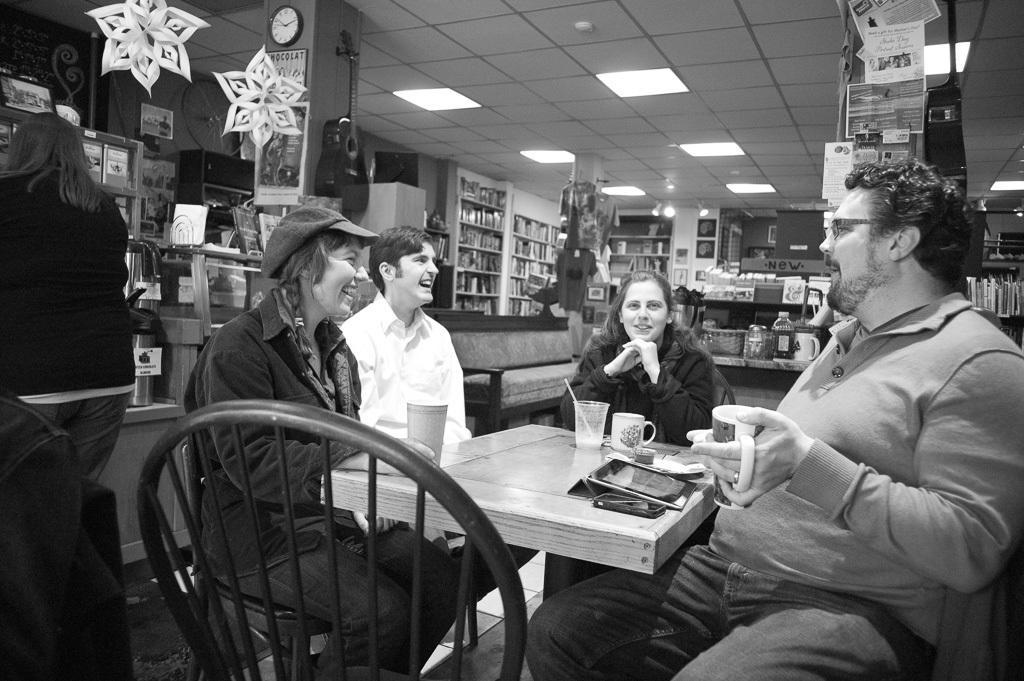How would you summarize this image in a sentence or two? There are four persons sitting on the chairs as we can see at the bottom of this image. We can see a mobile and glasses are kept on a table. There is a person standing on the left side of this image is wearing a black color dress, and we can see books and other objects are present in the background. 